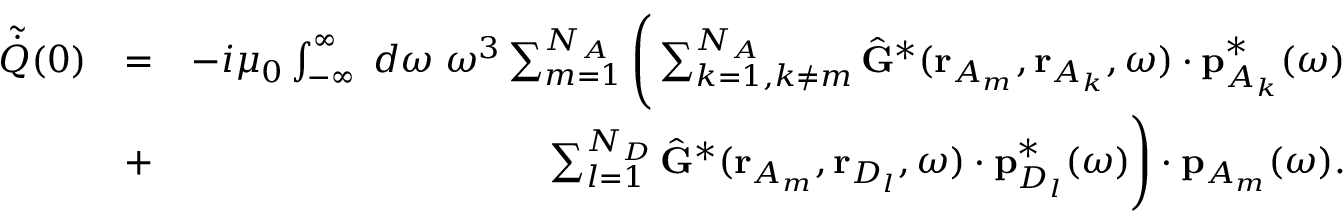Convert formula to latex. <formula><loc_0><loc_0><loc_500><loc_500>\begin{array} { r l r } { \tilde { \dot { Q } } ( 0 ) } & { = } & { - i \mu _ { 0 } \int _ { - \infty } ^ { \infty } \, d \omega \, \omega ^ { 3 } \sum _ { m = 1 } ^ { N _ { A } } \left ( \sum _ { k = 1 , k \neq m } ^ { N _ { A } } \hat { G } ^ { * } ( r _ { A _ { m } } , r _ { A _ { k } } , \omega ) \cdot p _ { { A _ { k } } } ^ { * } ( \omega ) } \\ & { + } & { \sum _ { l = 1 } ^ { N _ { D } } \hat { G } ^ { * } ( r _ { A _ { m } } , r _ { D _ { l } } , \omega ) \cdot p _ { D _ { l } } ^ { * } ( \omega ) \right ) \cdot { p } _ { A _ { m } } ( \omega ) . } \end{array}</formula> 